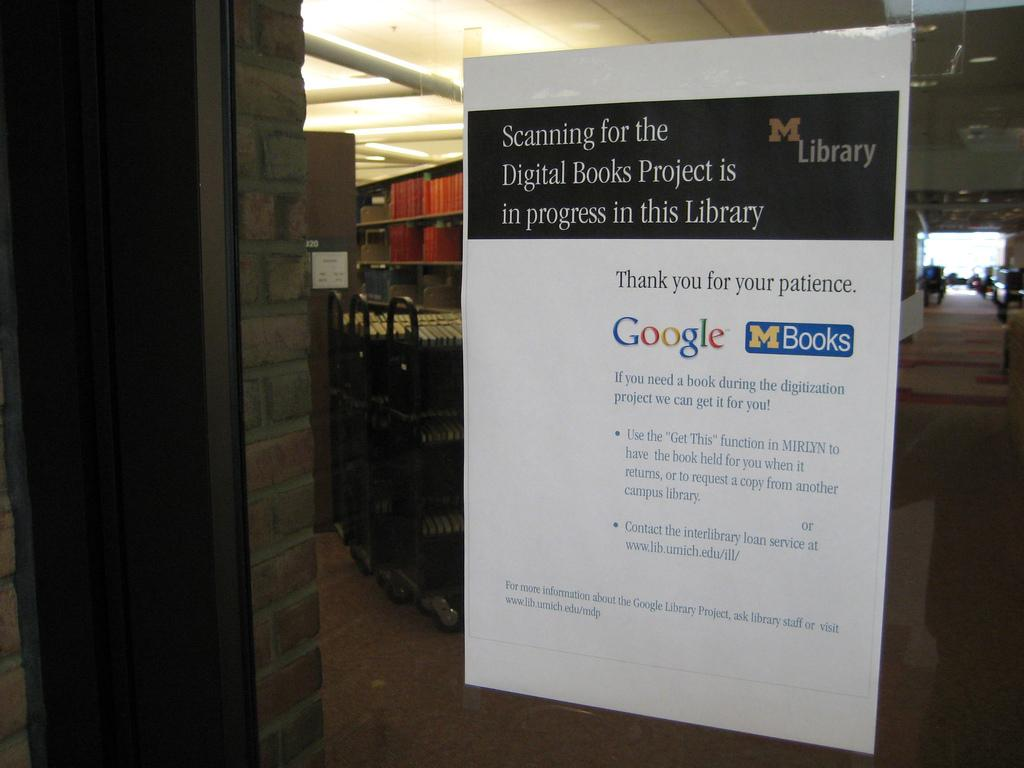<image>
Render a clear and concise summary of the photo. A sign hangs in the Michigan Library warning that there is scanning for a digital books project. 